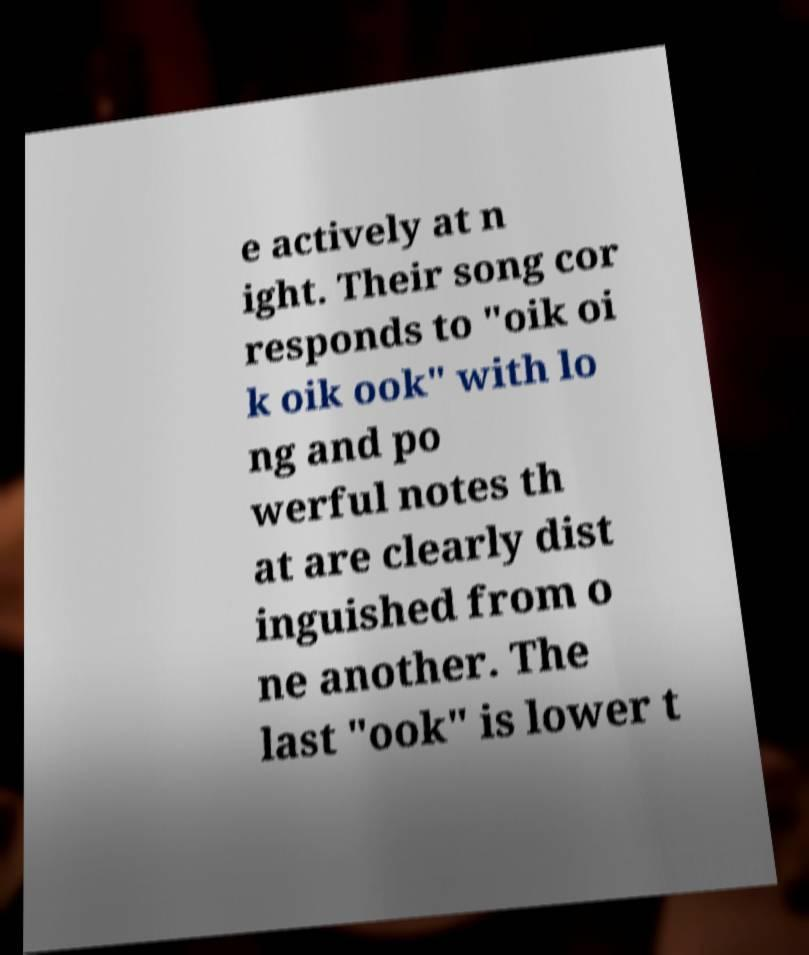Can you read and provide the text displayed in the image?This photo seems to have some interesting text. Can you extract and type it out for me? e actively at n ight. Their song cor responds to "oik oi k oik ook" with lo ng and po werful notes th at are clearly dist inguished from o ne another. The last "ook" is lower t 